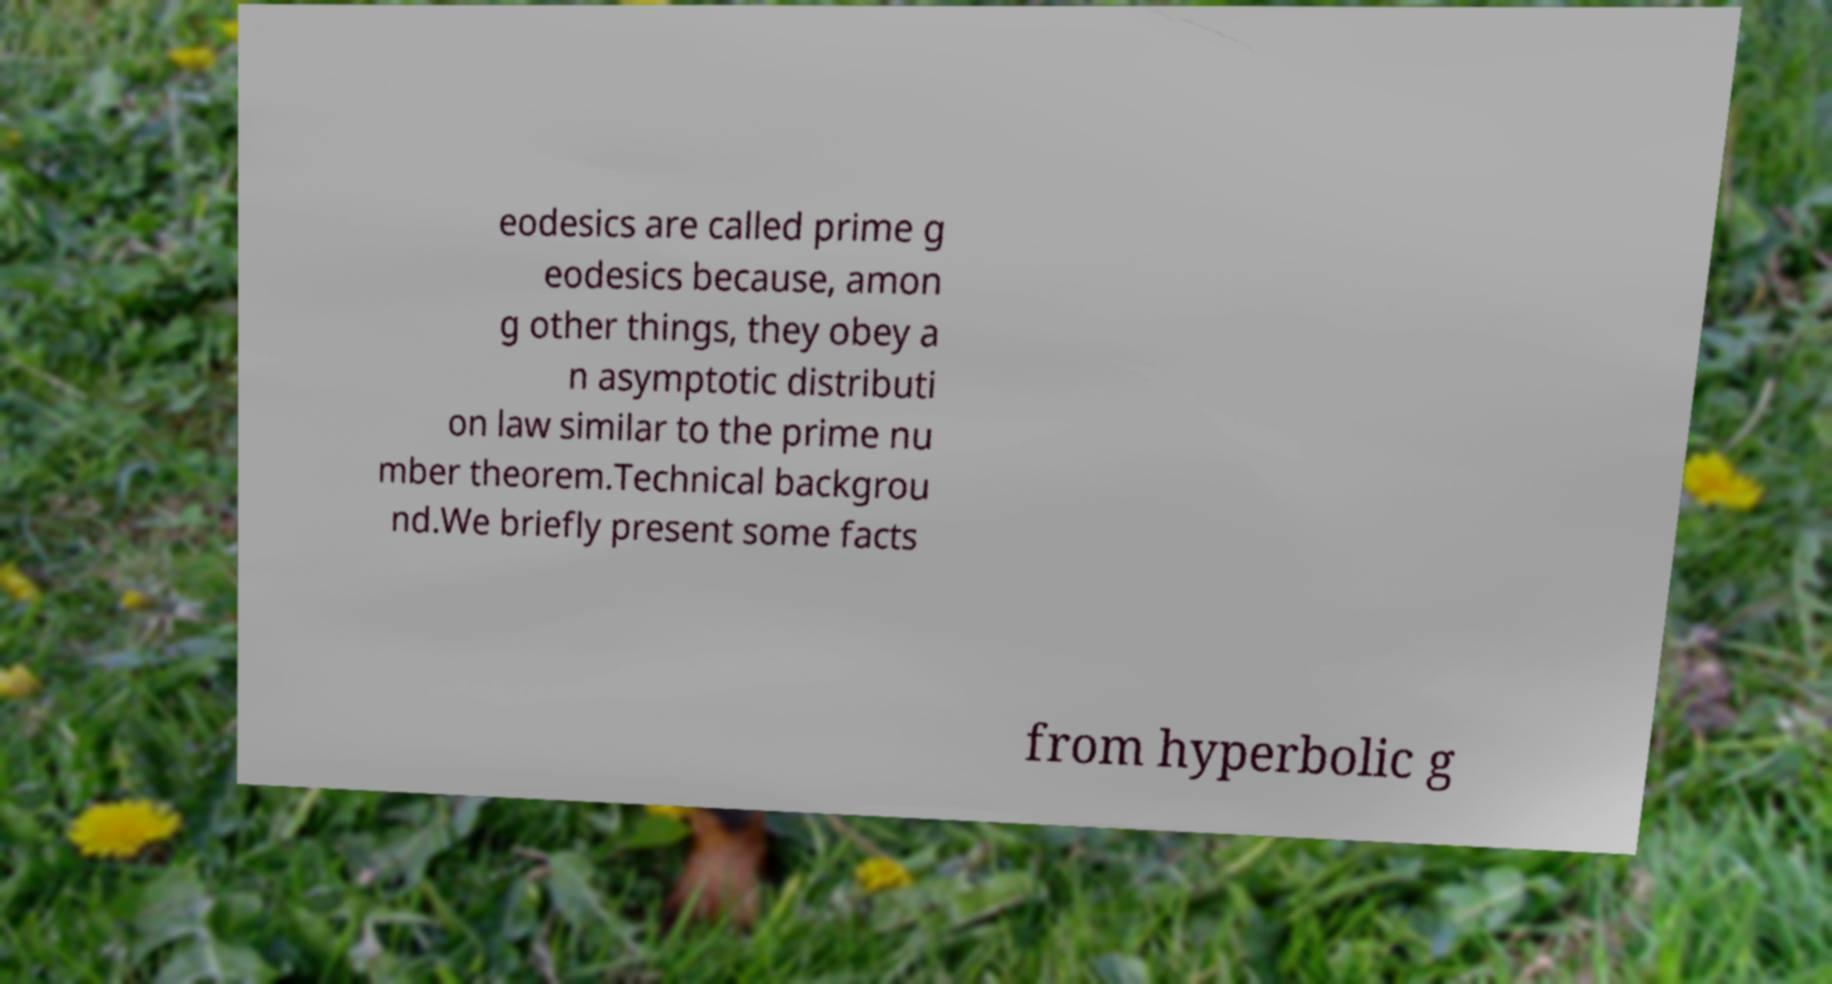Please identify and transcribe the text found in this image. eodesics are called prime g eodesics because, amon g other things, they obey a n asymptotic distributi on law similar to the prime nu mber theorem.Technical backgrou nd.We briefly present some facts from hyperbolic g 